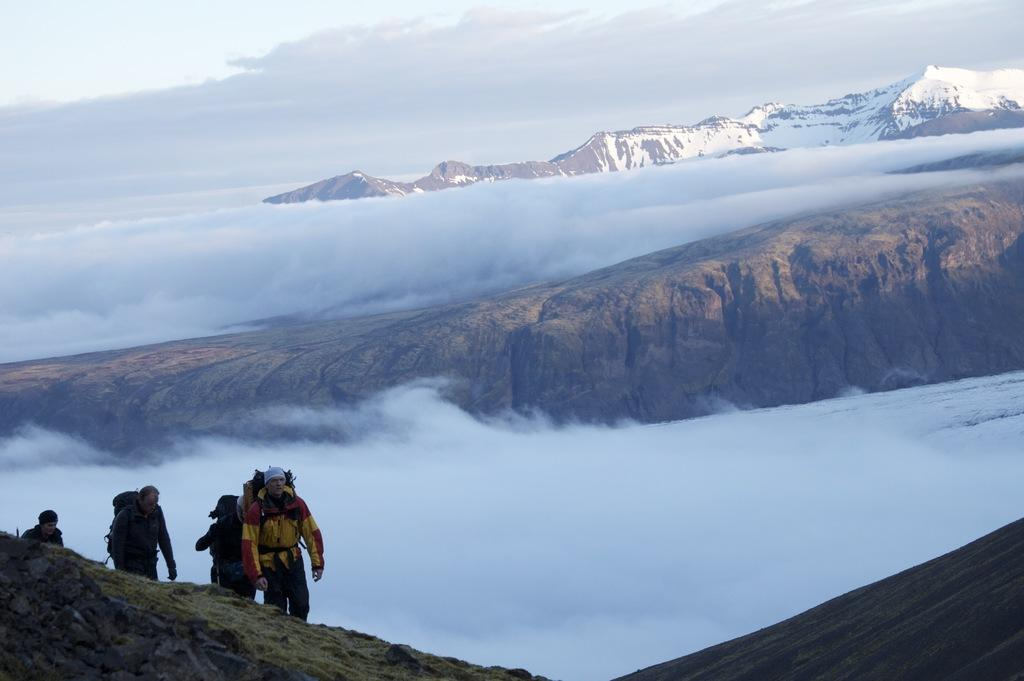What type of terrain is visible in the image? There are hills in the image. What natural features can be seen on the hills? There are rocks in the image. What are the people in the image doing? The people are climbing in the image. What might the people be carrying on their backs? The people are wearing backpacks on their backs. What type of chalk is being used by the people to draw on the rocks in the image? There is no chalk present in the image, and the people are not drawing on the rocks. How many chairs can be seen in the image? There are no chairs present in the image. 